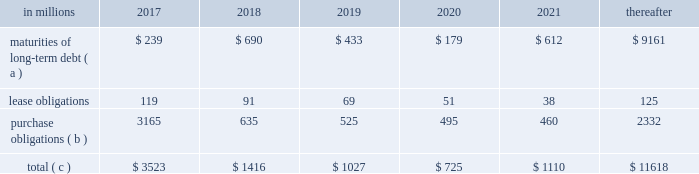Ilim holding s.a .
Shareholder 2019s agreement in october 2007 , in connection with the formation of the ilim holding s.a .
Joint venture , international paper entered into a shareholder 2019s agreement that includes provisions relating to the reconciliation of disputes among the partners .
This agreement provides that at any time , either the company or its partners may commence procedures specified under the deadlock agreement .
If these or any other deadlock procedures under the shareholder's agreement are commenced , although it is not obligated to do so , the company may in certain situations choose to purchase its partners' 50% ( 50 % ) interest in ilim .
Any such transaction would be subject to review and approval by russian and other relevant anti-trust authorities .
Based on the provisions of the agreement , the company estimates that the current purchase price for its partners' 50% ( 50 % ) interests would be approximately $ 1.5 billion , which could be satisfied by payment of cash or international paper common stock , or some combination of the two , at the company's option .
The purchase by the company of its partners 2019 50% ( 50 % ) interest in ilim would result in the consolidation of ilim's financial position and results of operations in all subsequent periods .
The parties have informed each other that they have no current intention to commence procedures specified under the deadlock provisions of the shareholder 2019s agreement .
Critical accounting policies and significant accounting estimates the preparation of financial statements in conformity with accounting principles generally accepted in the united states requires international paper to establish accounting policies and to make estimates that affect both the amounts and timing of the recording of assets , liabilities , revenues and expenses .
Some of these estimates require judgments about matters that are inherently uncertain .
Accounting policies whose application may have a significant effect on the reported results of operations and financial position of international paper , and that can require judgments by management that affect their application , include the accounting for contingencies , impairment or disposal of long-lived assets and goodwill , pensions and postretirement benefit obligations , stock options and income taxes .
The company has discussed the selection of critical accounting policies and the effect of significant estimates with the audit and finance committee of the company 2019s board of directors .
Contingent liabilities accruals for contingent liabilities , including legal and environmental matters , are recorded when it is probable that a liability has been incurred or an asset impaired and the amount of the loss can be reasonably estimated .
Liabilities accrued for legal matters require judgments regarding projected outcomes and range of loss based on historical experience and recommendations of legal counsel .
Liabilities for environmental matters require evaluations of relevant environmental regulations and estimates of future remediation alternatives and costs .
Impairment of long-lived assets and goodwill an impairment of a long-lived asset exists when the asset 2019s carrying amount exceeds its fair value , and is recorded when the carrying amount is not recoverable through cash flows from future operations .
A goodwill impairment exists when the carrying amount of goodwill exceeds its fair value .
Assessments of possible impairments of long-lived assets and goodwill are made when events or changes in circumstances indicate that the carrying value of the asset may not be recoverable through future operations .
Additionally , testing for possible impairment of goodwill and intangible asset balances is required annually .
The amount and timing of any impairment charges based on these assessments require the estimation of future cash flows and the fair market value of the related assets based on management 2019s best estimates of certain key factors , including future selling prices and volumes , operating , raw material , energy and freight costs , and various other projected operating economic factors .
As these key factors change in future periods , the company will update its impairment analyses to reflect its latest estimates and projections .
Under the provisions of accounting standards codification ( asc ) 350 , 201cintangibles 2013 goodwill and other , 201d the testing of goodwill for possible impairment is a two-step process .
In the first step , the fair value of the company 2019s reporting units is compared with their carrying value , including goodwill .
If fair value exceeds the carrying value , goodwill is not considered to be impaired .
If the fair value of a reporting unit is below the carrying value , then step two is performed to measure the amount of the goodwill impairment loss for the reporting unit .
This analysis requires the determination of the fair value of all of the individual assets and liabilities of the reporting unit , including any currently unrecognized intangible assets , as if the reporting unit had been purchased on the analysis date .
Once these fair values have been determined , the implied fair value of the unit 2019s goodwill is calculated as the excess , if any , of the fair value of the reporting unit determined in step one over the fair value of the net assets determined in step two .
The carrying value of goodwill is then reduced to this implied value , or to zero if the fair value of the assets exceeds the fair value of the reporting unit , through a goodwill impairment charge .
The impairment analysis requires a number of judgments by management .
In calculating the estimated fair value of its reporting units in step one , a total debt-to-capital ratio of less than 60% ( 60 % ) .
Net worth is defined as the sum of common stock , paid-in capital and retained earnings , less treasury stock plus any cumulative goodwill impairment charges .
The calculation also excludes accumulated other comprehensive income/loss and nonrecourse financial liabilities of special purpose entities .
The total debt-to-capital ratio is defined as total debt divided by the sum of total debt plus net worth .
The company was in compliance with all its debt covenants at december 31 , 2016 and was well below the thresholds stipulated under the covenants as defined in the credit agreements .
The company will continue to rely upon debt and capital markets for the majority of any necessary long-term funding not provided by operating cash flows .
Funding decisions will be guided by our capital structure planning objectives .
The primary goals of the company 2019s capital structure planning are to maximize financial flexibility and preserve liquidity while reducing interest expense .
The majority of international paper 2019s debt is accessed through global public capital markets where we have a wide base of investors .
Maintaining an investment grade credit rating is an important element of international paper 2019s financing strategy .
At december 31 , 2016 , the company held long-term credit ratings of bbb ( stable outlook ) and baa2 ( stable outlook ) by s&p and moody 2019s , respectively .
Contractual obligations for future payments under existing debt and lease commitments and purchase obligations at december 31 , 2016 , were as follows: .
( a ) total debt includes scheduled principal payments only .
( b ) includes $ 2 billion relating to fiber supply agreements entered into at the time of the 2006 transformation plan forestland sales and in conjunction with the 2008 acquisition of weyerhaeuser company 2019s containerboard , packaging and recycling business .
Also includes $ 1.1 billion relating to fiber supply agreements assumed in conjunction with the 2016 acquisition of weyerhaeuser's pulp business .
( c ) not included in the above table due to the uncertainty as to the amount and timing of the payment are unrecognized tax benefits of approximately $ 77 million .
We consider the undistributed earnings of our foreign subsidiaries as of december 31 , 2016 , to be indefinitely reinvested and , accordingly , no u.s .
Income taxes have been provided thereon .
As of december 31 , 2016 , the amount of cash associated with indefinitely reinvested foreign earnings was approximately $ 620 million .
We do not anticipate the need to repatriate funds to the united states to satisfy domestic liquidity needs arising in the ordinary course of business , including liquidity needs associated with our domestic debt service requirements .
Pension obligations and funding at december 31 , 2016 , the projected benefit obligation for the company 2019s u.s .
Defined benefit plans determined under u.s .
Gaap was approximately $ 3.4 billion higher than the fair value of plan assets .
Approximately $ 3.0 billion of this amount relates to plans that are subject to minimum funding requirements .
Under current irs funding rules , the calculation of minimum funding requirements differs from the calculation of the present value of plan benefits ( the projected benefit obligation ) for accounting purposes .
In december 2008 , the worker , retiree and employer recovery act of 2008 ( wera ) was passed by the u.s .
Congress which provided for pension funding relief and technical corrections .
Funding contributions depend on the funding method selected by the company , and the timing of its implementation , as well as on actual demographic data and the targeted funding level .
The company continually reassesses the amount and timing of any discretionary contributions and elected to make contributions totaling $ 750 million for both years ended december 31 , 2016 and 2015 .
At this time , we do not expect to have any required contributions to our plans in 2017 , although the company may elect to make future voluntary contributions .
The timing and amount of future contributions , which could be material , will depend on a number of factors , including the actual earnings and changes in values of plan assets and changes in interest rates .
International paper announced a voluntary , limited-time opportunity for former employees who are participants in the retirement plan of international paper company ( the pension plan ) to request early payment of their entire pension plan benefit in the form of a single lump sum payment .
The amount of total payments under this program was approximately $ 1.2 billion , and were made from plan trust assets on june 30 , 2016 .
Based on the level of payments made , settlement accounting rules applied and resulted in a plan remeasurement as of the june 30 , 2016 payment date .
As a result of settlement accounting , the company recognized a pro-rata portion of the unamortized net actuarial loss , after remeasurement , resulting in a $ 439 million non-cash charge to the company's earnings in the second quarter of 2016 .
Additional payments of $ 8 million and $ 9 million were made during the third and fourth quarters , respectively , due to mandatory cash payouts and a small lump sum payout , and the pension plan was subsequently remeasured at september 30 , 2016 and december 31 , 2016 .
As a result of settlement accounting , the company recognized non-cash settlement charges of $ 3 million in both the third and fourth quarters of 2016. .
In 2018 what percentage of contractual obligations for future payments under existing debt and lease commitments and purchase obligations at december 31 , 2016 is due to maturities of long-term debt? 
Computations: (690 / 1416)
Answer: 0.48729. 